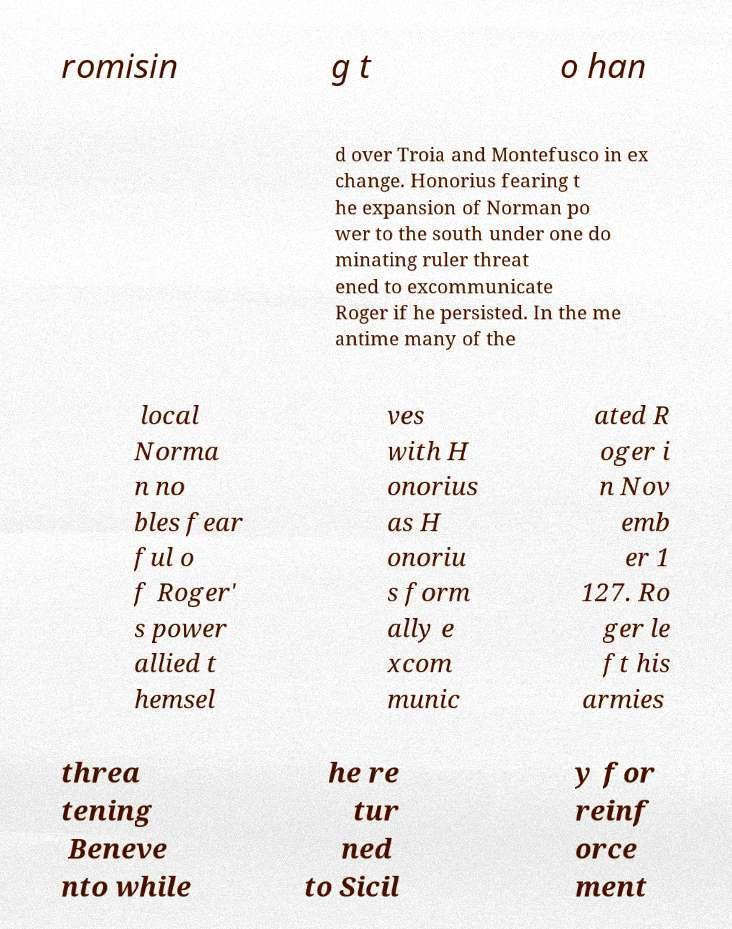Can you accurately transcribe the text from the provided image for me? romisin g t o han d over Troia and Montefusco in ex change. Honorius fearing t he expansion of Norman po wer to the south under one do minating ruler threat ened to excommunicate Roger if he persisted. In the me antime many of the local Norma n no bles fear ful o f Roger' s power allied t hemsel ves with H onorius as H onoriu s form ally e xcom munic ated R oger i n Nov emb er 1 127. Ro ger le ft his armies threa tening Beneve nto while he re tur ned to Sicil y for reinf orce ment 